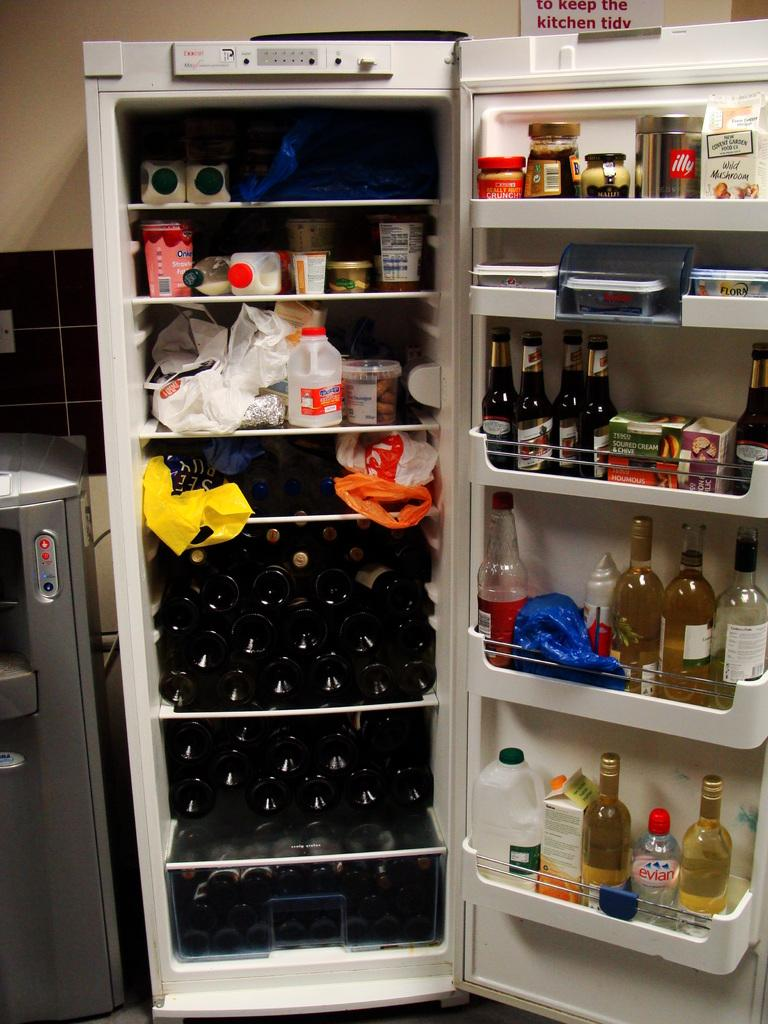<image>
Summarize the visual content of the image. A bottle of Evian water sits on the bottom shelf of a cluttered refrigerator 